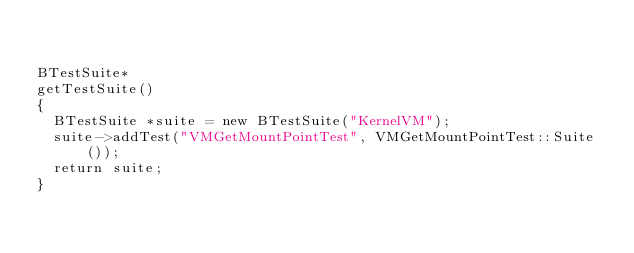<code> <loc_0><loc_0><loc_500><loc_500><_C++_>

BTestSuite*
getTestSuite()
{
	BTestSuite *suite = new BTestSuite("KernelVM");
	suite->addTest("VMGetMountPointTest", VMGetMountPointTest::Suite());
	return suite;
}
</code> 